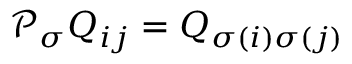Convert formula to latex. <formula><loc_0><loc_0><loc_500><loc_500>\mathcal { P } _ { \sigma } Q _ { i j } = Q _ { \sigma ( i ) \sigma ( j ) }</formula> 